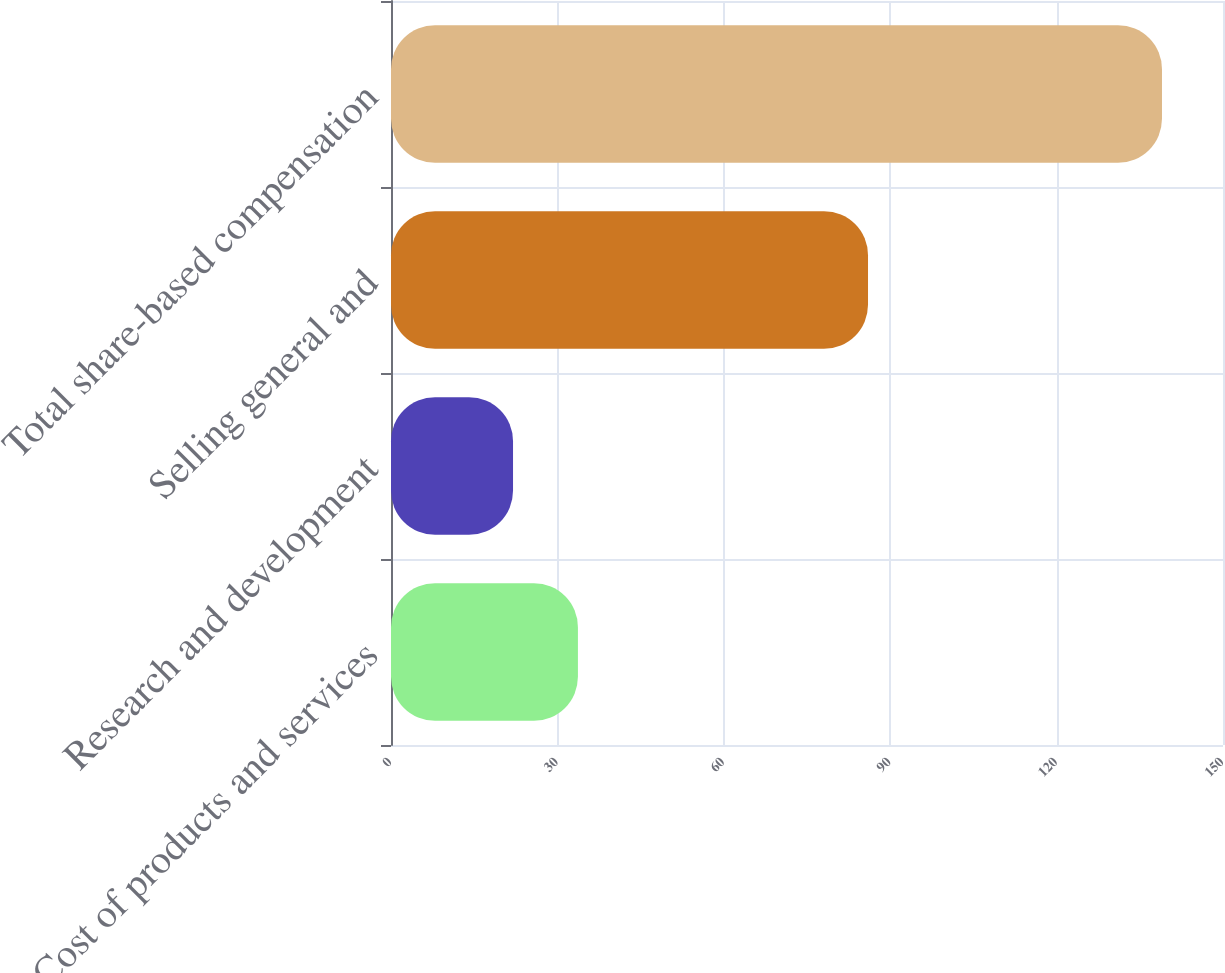Convert chart to OTSL. <chart><loc_0><loc_0><loc_500><loc_500><bar_chart><fcel>Cost of products and services<fcel>Research and development<fcel>Selling general and<fcel>Total share-based compensation<nl><fcel>33.7<fcel>22<fcel>86<fcel>139<nl></chart> 